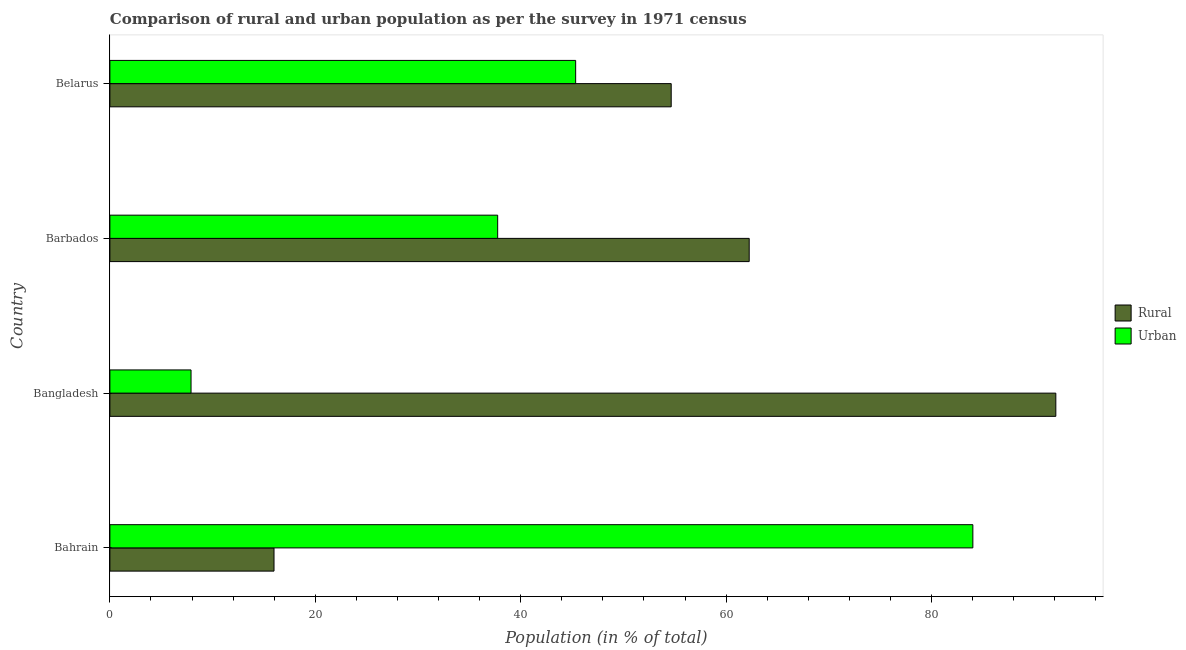Are the number of bars per tick equal to the number of legend labels?
Provide a short and direct response. Yes. How many bars are there on the 3rd tick from the bottom?
Provide a short and direct response. 2. What is the label of the 4th group of bars from the top?
Offer a very short reply. Bahrain. What is the rural population in Bahrain?
Provide a succinct answer. 15.98. Across all countries, what is the maximum rural population?
Give a very brief answer. 92.1. Across all countries, what is the minimum rural population?
Provide a succinct answer. 15.98. In which country was the rural population minimum?
Give a very brief answer. Bahrain. What is the total rural population in the graph?
Give a very brief answer. 224.97. What is the difference between the urban population in Bahrain and that in Barbados?
Offer a very short reply. 46.27. What is the difference between the urban population in Barbados and the rural population in Belarus?
Keep it short and to the point. -16.9. What is the average urban population per country?
Provide a short and direct response. 43.76. What is the difference between the urban population and rural population in Barbados?
Ensure brevity in your answer.  -24.49. In how many countries, is the rural population greater than 60 %?
Make the answer very short. 2. What is the ratio of the urban population in Bahrain to that in Bangladesh?
Your answer should be compact. 10.63. What is the difference between the highest and the second highest rural population?
Provide a short and direct response. 29.85. What is the difference between the highest and the lowest urban population?
Your answer should be very brief. 76.12. In how many countries, is the urban population greater than the average urban population taken over all countries?
Provide a succinct answer. 2. What does the 2nd bar from the top in Bahrain represents?
Give a very brief answer. Rural. What does the 1st bar from the bottom in Belarus represents?
Keep it short and to the point. Rural. Are all the bars in the graph horizontal?
Offer a terse response. Yes. Does the graph contain any zero values?
Your answer should be compact. No. Does the graph contain grids?
Keep it short and to the point. No. How many legend labels are there?
Offer a terse response. 2. What is the title of the graph?
Ensure brevity in your answer.  Comparison of rural and urban population as per the survey in 1971 census. Does "Drinking water services" appear as one of the legend labels in the graph?
Ensure brevity in your answer.  No. What is the label or title of the X-axis?
Your response must be concise. Population (in % of total). What is the label or title of the Y-axis?
Give a very brief answer. Country. What is the Population (in % of total) in Rural in Bahrain?
Make the answer very short. 15.98. What is the Population (in % of total) in Urban in Bahrain?
Keep it short and to the point. 84.02. What is the Population (in % of total) in Rural in Bangladesh?
Your response must be concise. 92.1. What is the Population (in % of total) of Urban in Bangladesh?
Give a very brief answer. 7.9. What is the Population (in % of total) of Rural in Barbados?
Make the answer very short. 62.24. What is the Population (in % of total) in Urban in Barbados?
Your answer should be very brief. 37.76. What is the Population (in % of total) of Rural in Belarus?
Ensure brevity in your answer.  54.65. What is the Population (in % of total) of Urban in Belarus?
Your answer should be compact. 45.35. Across all countries, what is the maximum Population (in % of total) in Rural?
Ensure brevity in your answer.  92.1. Across all countries, what is the maximum Population (in % of total) in Urban?
Provide a short and direct response. 84.02. Across all countries, what is the minimum Population (in % of total) in Rural?
Make the answer very short. 15.98. Across all countries, what is the minimum Population (in % of total) of Urban?
Your response must be concise. 7.9. What is the total Population (in % of total) in Rural in the graph?
Offer a terse response. 224.97. What is the total Population (in % of total) in Urban in the graph?
Offer a very short reply. 175.03. What is the difference between the Population (in % of total) of Rural in Bahrain and that in Bangladesh?
Keep it short and to the point. -76.12. What is the difference between the Population (in % of total) in Urban in Bahrain and that in Bangladesh?
Your answer should be compact. 76.12. What is the difference between the Population (in % of total) of Rural in Bahrain and that in Barbados?
Keep it short and to the point. -46.27. What is the difference between the Population (in % of total) of Urban in Bahrain and that in Barbados?
Your answer should be compact. 46.27. What is the difference between the Population (in % of total) in Rural in Bahrain and that in Belarus?
Make the answer very short. -38.67. What is the difference between the Population (in % of total) of Urban in Bahrain and that in Belarus?
Make the answer very short. 38.67. What is the difference between the Population (in % of total) in Rural in Bangladesh and that in Barbados?
Keep it short and to the point. 29.85. What is the difference between the Population (in % of total) of Urban in Bangladesh and that in Barbados?
Make the answer very short. -29.85. What is the difference between the Population (in % of total) of Rural in Bangladesh and that in Belarus?
Your response must be concise. 37.45. What is the difference between the Population (in % of total) in Urban in Bangladesh and that in Belarus?
Offer a very short reply. -37.45. What is the difference between the Population (in % of total) in Rural in Barbados and that in Belarus?
Offer a terse response. 7.59. What is the difference between the Population (in % of total) in Urban in Barbados and that in Belarus?
Make the answer very short. -7.59. What is the difference between the Population (in % of total) in Rural in Bahrain and the Population (in % of total) in Urban in Bangladesh?
Your answer should be compact. 8.08. What is the difference between the Population (in % of total) of Rural in Bahrain and the Population (in % of total) of Urban in Barbados?
Provide a short and direct response. -21.78. What is the difference between the Population (in % of total) in Rural in Bahrain and the Population (in % of total) in Urban in Belarus?
Provide a succinct answer. -29.37. What is the difference between the Population (in % of total) in Rural in Bangladesh and the Population (in % of total) in Urban in Barbados?
Ensure brevity in your answer.  54.34. What is the difference between the Population (in % of total) in Rural in Bangladesh and the Population (in % of total) in Urban in Belarus?
Provide a short and direct response. 46.75. What is the difference between the Population (in % of total) in Rural in Barbados and the Population (in % of total) in Urban in Belarus?
Ensure brevity in your answer.  16.9. What is the average Population (in % of total) of Rural per country?
Your answer should be compact. 56.24. What is the average Population (in % of total) of Urban per country?
Ensure brevity in your answer.  43.76. What is the difference between the Population (in % of total) in Rural and Population (in % of total) in Urban in Bahrain?
Provide a short and direct response. -68.04. What is the difference between the Population (in % of total) in Rural and Population (in % of total) in Urban in Bangladesh?
Your answer should be compact. 84.2. What is the difference between the Population (in % of total) of Rural and Population (in % of total) of Urban in Barbados?
Your answer should be very brief. 24.49. What is the difference between the Population (in % of total) of Rural and Population (in % of total) of Urban in Belarus?
Your response must be concise. 9.3. What is the ratio of the Population (in % of total) of Rural in Bahrain to that in Bangladesh?
Keep it short and to the point. 0.17. What is the ratio of the Population (in % of total) in Urban in Bahrain to that in Bangladesh?
Provide a short and direct response. 10.63. What is the ratio of the Population (in % of total) in Rural in Bahrain to that in Barbados?
Provide a short and direct response. 0.26. What is the ratio of the Population (in % of total) of Urban in Bahrain to that in Barbados?
Your response must be concise. 2.23. What is the ratio of the Population (in % of total) of Rural in Bahrain to that in Belarus?
Make the answer very short. 0.29. What is the ratio of the Population (in % of total) in Urban in Bahrain to that in Belarus?
Make the answer very short. 1.85. What is the ratio of the Population (in % of total) in Rural in Bangladesh to that in Barbados?
Your response must be concise. 1.48. What is the ratio of the Population (in % of total) in Urban in Bangladesh to that in Barbados?
Make the answer very short. 0.21. What is the ratio of the Population (in % of total) of Rural in Bangladesh to that in Belarus?
Provide a short and direct response. 1.69. What is the ratio of the Population (in % of total) in Urban in Bangladesh to that in Belarus?
Keep it short and to the point. 0.17. What is the ratio of the Population (in % of total) in Rural in Barbados to that in Belarus?
Give a very brief answer. 1.14. What is the ratio of the Population (in % of total) of Urban in Barbados to that in Belarus?
Provide a short and direct response. 0.83. What is the difference between the highest and the second highest Population (in % of total) of Rural?
Keep it short and to the point. 29.85. What is the difference between the highest and the second highest Population (in % of total) in Urban?
Offer a terse response. 38.67. What is the difference between the highest and the lowest Population (in % of total) in Rural?
Keep it short and to the point. 76.12. What is the difference between the highest and the lowest Population (in % of total) in Urban?
Offer a very short reply. 76.12. 